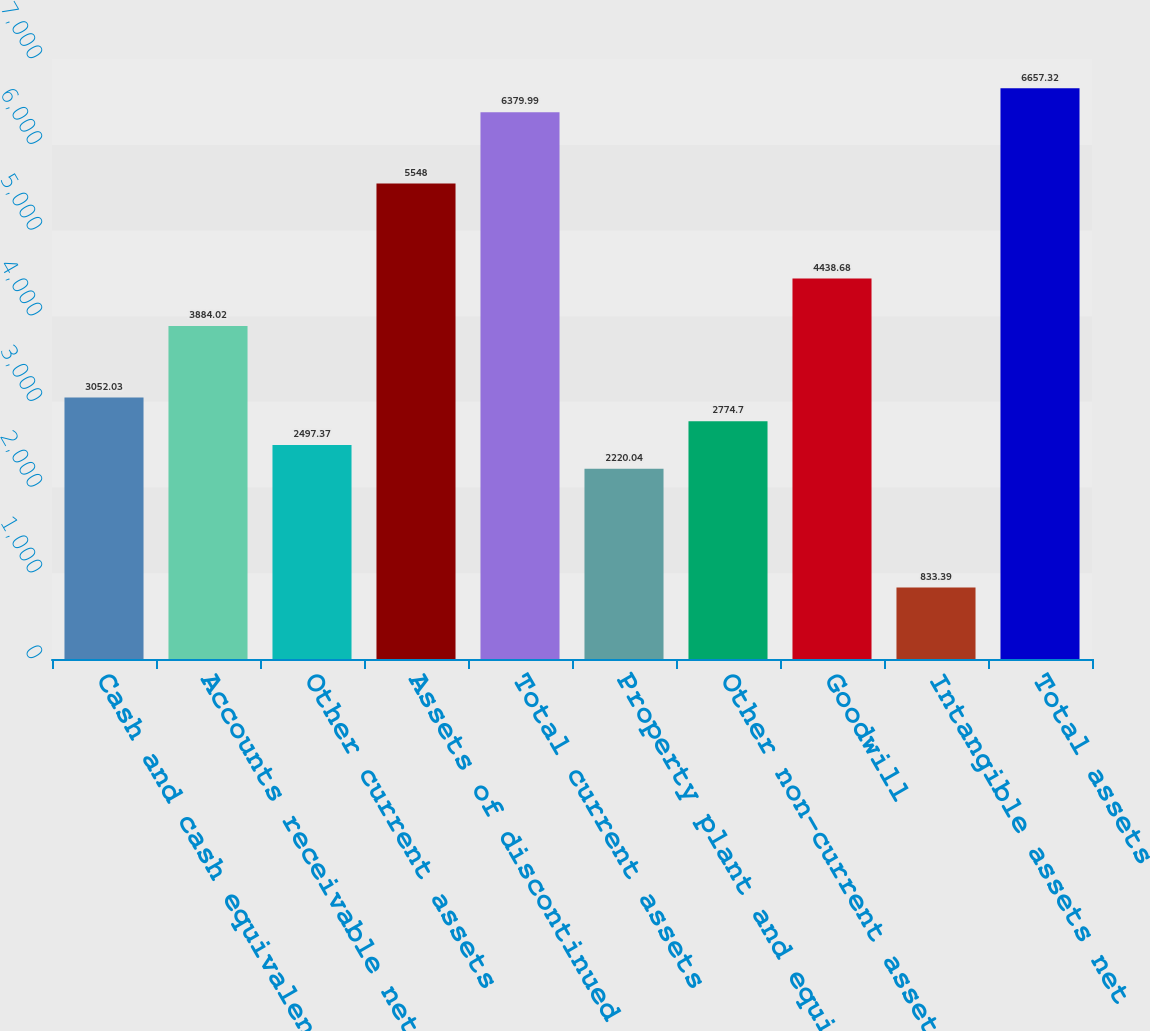<chart> <loc_0><loc_0><loc_500><loc_500><bar_chart><fcel>Cash and cash equivalents<fcel>Accounts receivable net of<fcel>Other current assets<fcel>Assets of discontinued<fcel>Total current assets<fcel>Property plant and equipment<fcel>Other non-current assets<fcel>Goodwill<fcel>Intangible assets net<fcel>Total assets<nl><fcel>3052.03<fcel>3884.02<fcel>2497.37<fcel>5548<fcel>6379.99<fcel>2220.04<fcel>2774.7<fcel>4438.68<fcel>833.39<fcel>6657.32<nl></chart> 